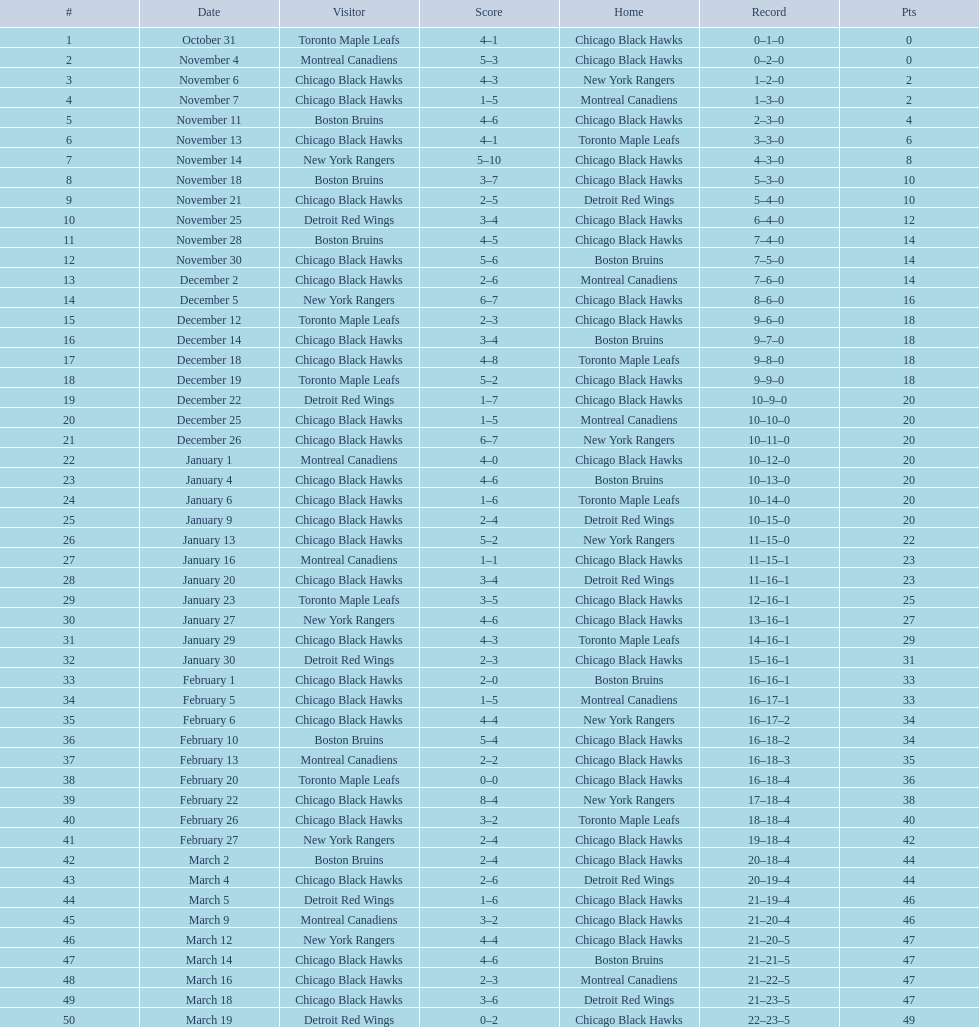What is the variation in points between december 5th and november 11th? 3. 